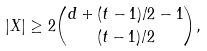<formula> <loc_0><loc_0><loc_500><loc_500>| X | \geq 2 \binom { d + ( t - 1 ) / 2 - 1 } { ( t - 1 ) / 2 } ,</formula> 